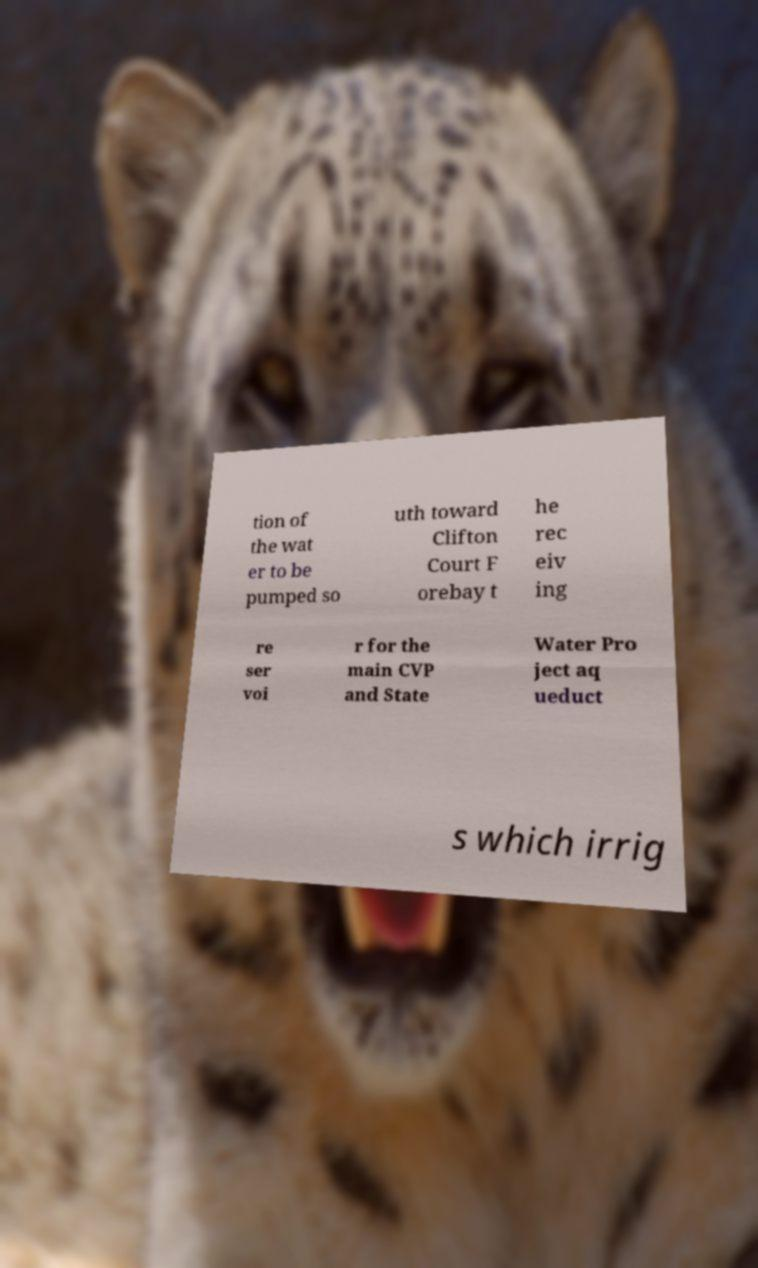Could you extract and type out the text from this image? tion of the wat er to be pumped so uth toward Clifton Court F orebay t he rec eiv ing re ser voi r for the main CVP and State Water Pro ject aq ueduct s which irrig 